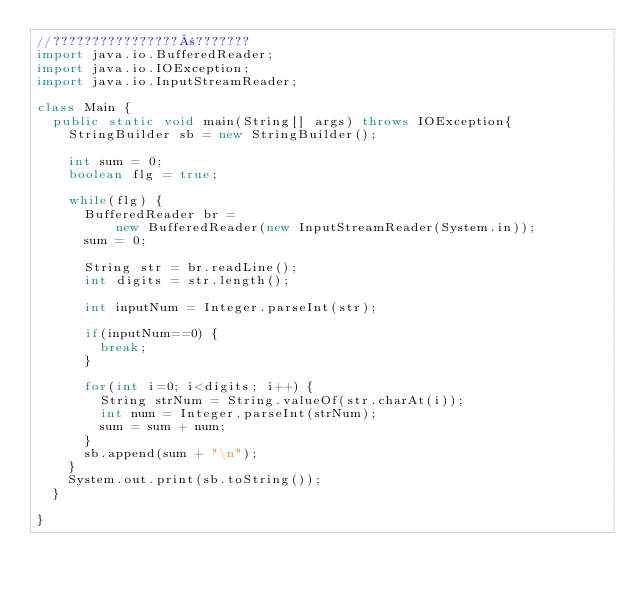Convert code to text. <code><loc_0><loc_0><loc_500><loc_500><_Java_>//????????????????±???????
import java.io.BufferedReader;
import java.io.IOException;
import java.io.InputStreamReader;

class Main {
	public static void main(String[] args) throws IOException{
		StringBuilder sb = new StringBuilder();
		
		int sum = 0;
		boolean flg = true;
		
		while(flg) {
			BufferedReader br =
					new BufferedReader(new InputStreamReader(System.in));
			sum = 0;
			
			String str = br.readLine();
			int digits = str.length();		
			
			int inputNum = Integer.parseInt(str);
			
			if(inputNum==0) {
				break;
			}

			for(int i=0; i<digits; i++) {
				String strNum = String.valueOf(str.charAt(i));
				int num = Integer.parseInt(strNum);
				sum = sum + num;
			}
			sb.append(sum + "\n");
		}
		System.out.print(sb.toString());
	}

}</code> 